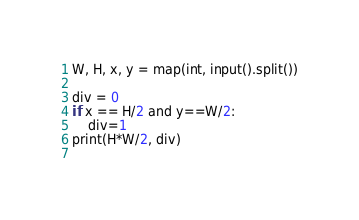Convert code to text. <code><loc_0><loc_0><loc_500><loc_500><_Python_>W, H, x, y = map(int, input().split())

div = 0
if x == H/2 and y==W/2:
    div=1
print(H*W/2, div)
 
</code> 